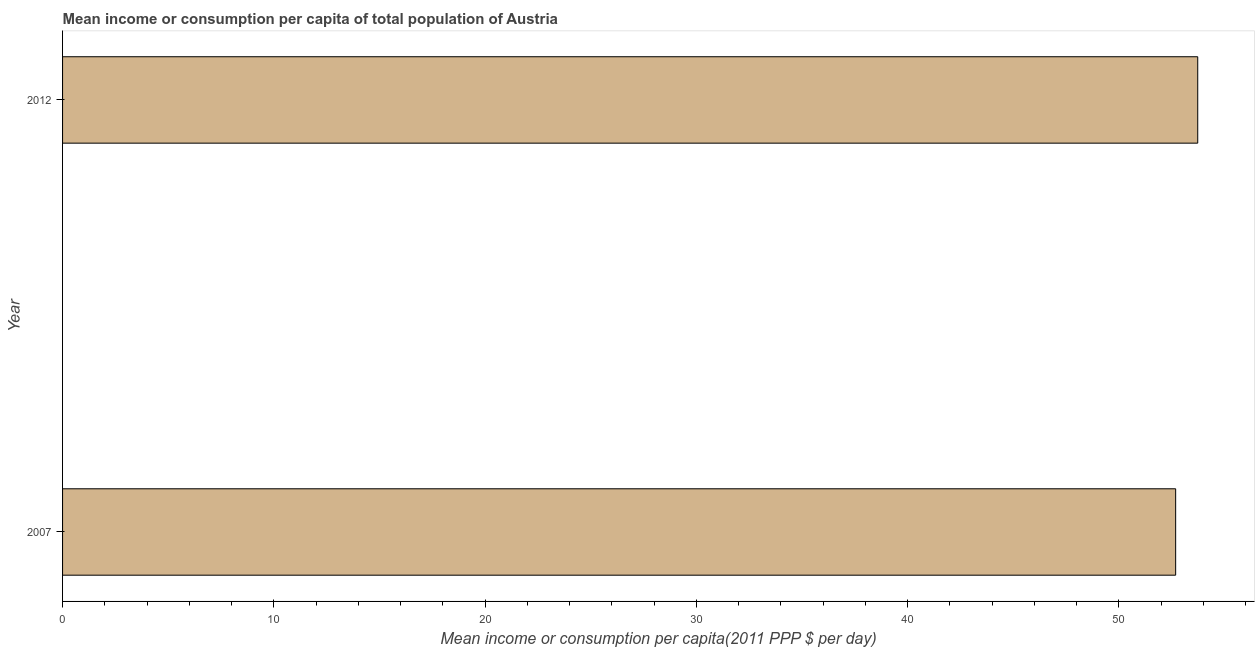Does the graph contain any zero values?
Your answer should be very brief. No. Does the graph contain grids?
Offer a terse response. No. What is the title of the graph?
Provide a succinct answer. Mean income or consumption per capita of total population of Austria. What is the label or title of the X-axis?
Make the answer very short. Mean income or consumption per capita(2011 PPP $ per day). What is the label or title of the Y-axis?
Your response must be concise. Year. What is the mean income or consumption in 2012?
Make the answer very short. 53.73. Across all years, what is the maximum mean income or consumption?
Provide a succinct answer. 53.73. Across all years, what is the minimum mean income or consumption?
Make the answer very short. 52.68. In which year was the mean income or consumption maximum?
Offer a very short reply. 2012. In which year was the mean income or consumption minimum?
Your answer should be very brief. 2007. What is the sum of the mean income or consumption?
Your answer should be very brief. 106.41. What is the difference between the mean income or consumption in 2007 and 2012?
Offer a terse response. -1.04. What is the average mean income or consumption per year?
Give a very brief answer. 53.21. What is the median mean income or consumption?
Provide a succinct answer. 53.21. What is the ratio of the mean income or consumption in 2007 to that in 2012?
Ensure brevity in your answer.  0.98. How many years are there in the graph?
Offer a terse response. 2. What is the difference between two consecutive major ticks on the X-axis?
Your response must be concise. 10. What is the Mean income or consumption per capita(2011 PPP $ per day) of 2007?
Offer a terse response. 52.68. What is the Mean income or consumption per capita(2011 PPP $ per day) of 2012?
Offer a very short reply. 53.73. What is the difference between the Mean income or consumption per capita(2011 PPP $ per day) in 2007 and 2012?
Ensure brevity in your answer.  -1.04. What is the ratio of the Mean income or consumption per capita(2011 PPP $ per day) in 2007 to that in 2012?
Make the answer very short. 0.98. 